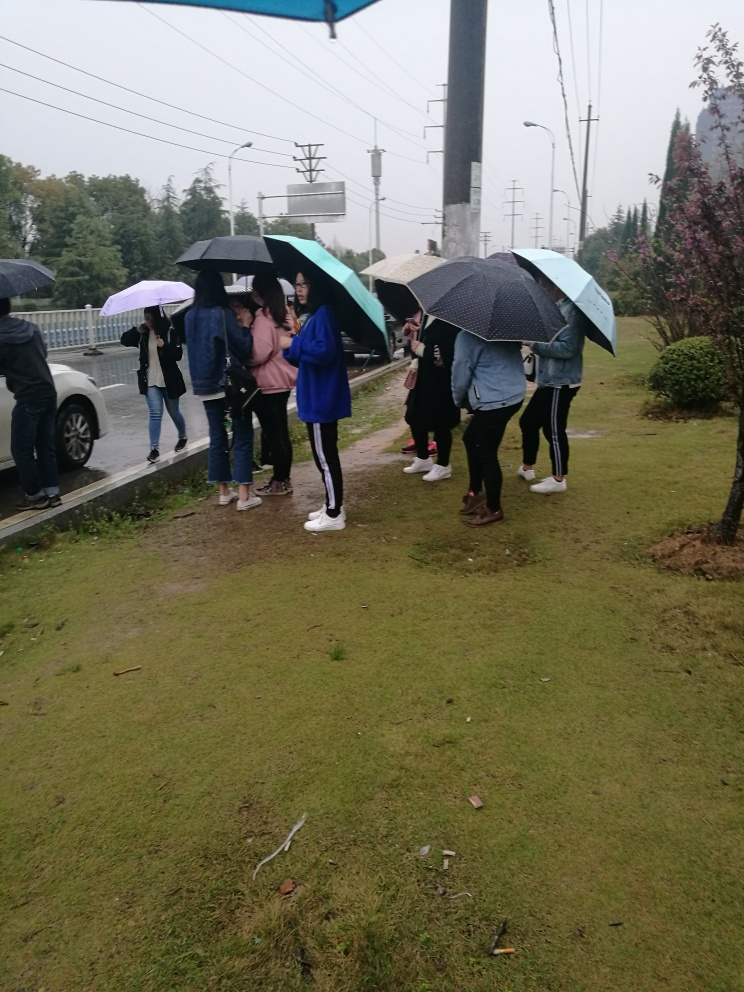What weather condition is depicted in the image? The people are using umbrellas, which typically indicates rainy conditions. The sky also appears to be overcast, supporting this observation. Do the people in the image seem to be waiting for something, and if so, what clues suggest that? Yes, the orientation and positioning of the people suggest that they might be waiting for transportation, such as a bus, given their grouping by the roadside and the general direction of their gaze. 